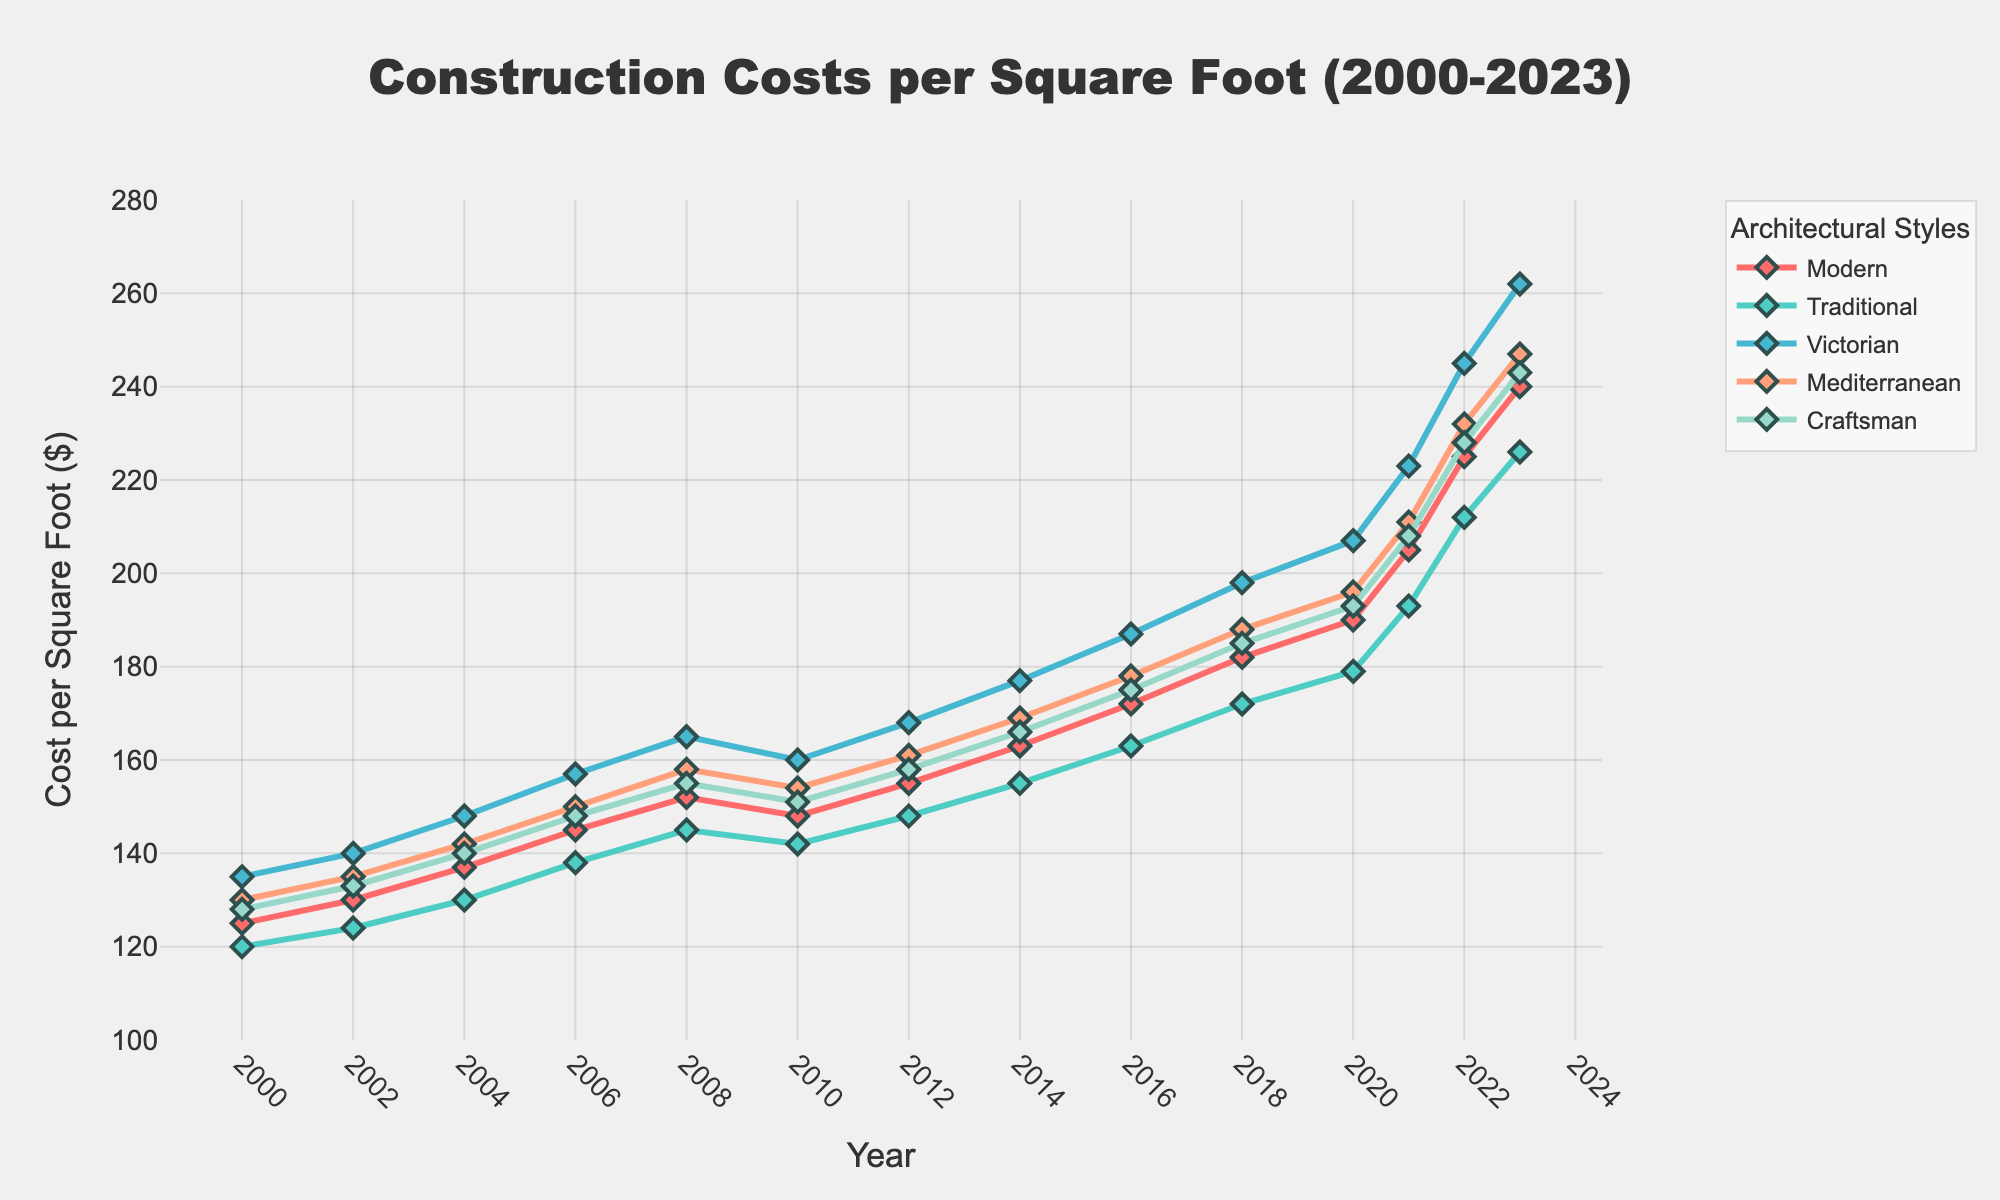How have construction costs for the Mediterranean style changed from 2000 to 2023? The cost for Mediterranean style started at $130 per square foot in 2000 and increased to $247 per square foot in 2023. The difference in cost is calculated by subtracting the 2000 cost from the 2023 cost: $247 - $130 = $117.
Answer: The costs increased by $117 Which architectural style experienced the highest increase in cost per square foot from 2000 to 2023? To determine the highest increase, look at the difference between the costs in 2023 and 2000 for each style: Modern = $240 - $125 = $115, Traditional = $226 - $120 = $106, Victorian = $262 - $135 = $127, Mediterranean = $247 - $130 = $117, Craftsman = $243 - $128 = $115. The Victorian style experienced the highest cost increase.
Answer: Victorian Between which years did Modern style experience the largest increase in cost per square foot? To identify the largest increase, observe the year-to-year changes for Modern style. The largest increase occurs between 2020 ($190) and 2021 ($205): $205 - $190 = $15.
Answer: 2020 to 2021 Compare the cost per square foot of Craftsman and Traditional styles in 2023. Which one is higher and by how much? In 2023, Craftsman costs $243 per square foot, while Traditional costs $226 per square foot. The cost difference is $243 - $226 = $17. Craftsman style is higher by $17.
Answer: Craftsman by $17 What is the trend in construction costs for the Victorian style from 2000 to 2023? The Victorian style shows a steady increase over the years from $135 in 2000 to $262 in 2023. This consistent upward trend indicates rising costs.
Answer: Steady increase In which year did the Craftsman style first surpass a cost of $200 per square foot? The Craftsman style first surpassed $200 per square foot in 2021 with a cost of $208.
Answer: 2021 Across all styles, which year saw the highest construction costs? By examining the cost values in each year for all styles, the highest cost is found in 2023 for the Victorian style at $262 per square foot.
Answer: 2023 What was the average cost increase per style from 2000 to 2023? For each style, subtract the 2000 value from the 2023 value: Modern: $240 - $125 = $115, Traditional: $226 - $120 = $106, Victorian: $262 - $135 = $127, Mediterranean: $247 - $130 = $117, Craftsman: $243 - $128 = $115. The averages of these increases are: (115 + 106 + 127 + 117 + 115) / 5 = 116.
Answer: $116 